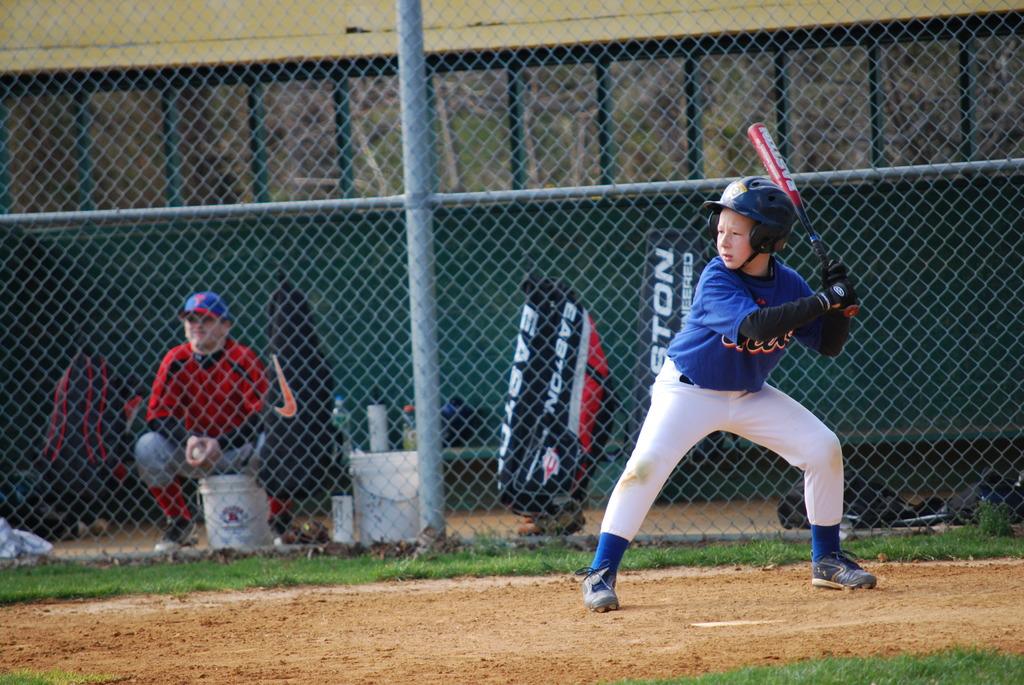Is that an easton bag?
Ensure brevity in your answer.  Yes. 